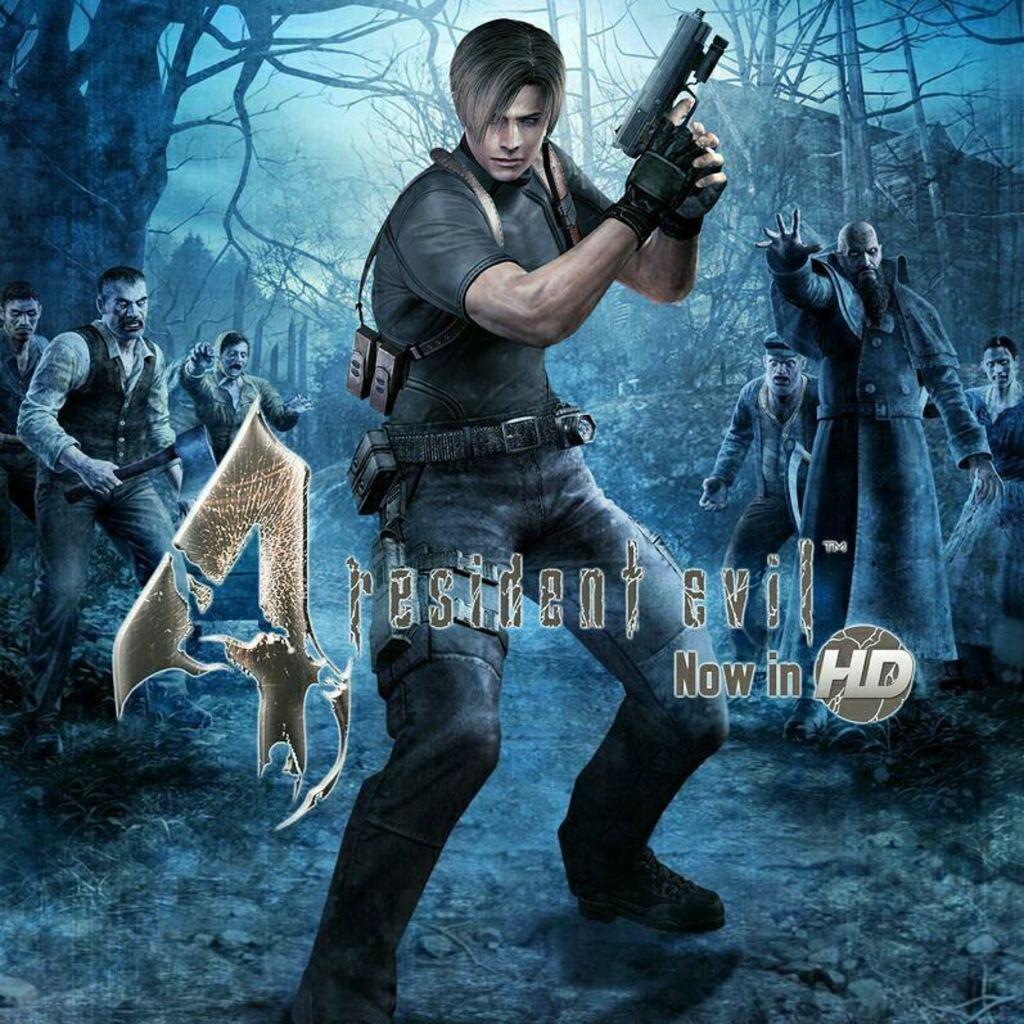In one or two sentences, can you explain what this image depicts? In the picture I can see an image of a person standing and holding a gun in his hands and there is resident evil now in HD written on it and there are few other persons,trees and buildings in the background. 